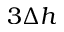Convert formula to latex. <formula><loc_0><loc_0><loc_500><loc_500>3 \Delta { h }</formula> 